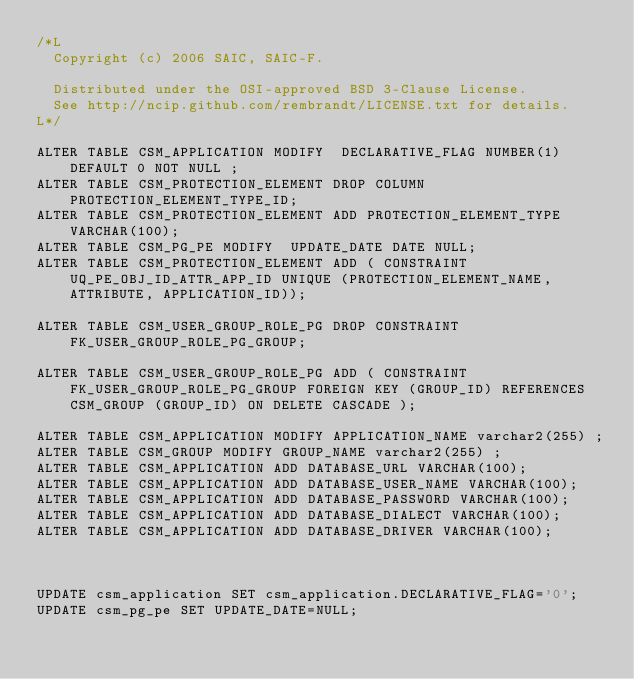Convert code to text. <code><loc_0><loc_0><loc_500><loc_500><_SQL_>/*L
  Copyright (c) 2006 SAIC, SAIC-F.

  Distributed under the OSI-approved BSD 3-Clause License.
  See http://ncip.github.com/rembrandt/LICENSE.txt for details.
L*/

ALTER TABLE CSM_APPLICATION MODIFY  DECLARATIVE_FLAG NUMBER(1) DEFAULT 0 NOT NULL ;
ALTER TABLE CSM_PROTECTION_ELEMENT DROP COLUMN PROTECTION_ELEMENT_TYPE_ID;
ALTER TABLE CSM_PROTECTION_ELEMENT ADD PROTECTION_ELEMENT_TYPE VARCHAR(100);
ALTER TABLE CSM_PG_PE MODIFY  UPDATE_DATE DATE NULL;
ALTER TABLE CSM_PROTECTION_ELEMENT ADD ( CONSTRAINT UQ_PE_OBJ_ID_ATTR_APP_ID UNIQUE (PROTECTION_ELEMENT_NAME, ATTRIBUTE, APPLICATION_ID));

ALTER TABLE CSM_USER_GROUP_ROLE_PG DROP CONSTRAINT FK_USER_GROUP_ROLE_PG_GROUP;

ALTER TABLE CSM_USER_GROUP_ROLE_PG ADD ( CONSTRAINT FK_USER_GROUP_ROLE_PG_GROUP FOREIGN KEY (GROUP_ID) REFERENCES CSM_GROUP (GROUP_ID) ON DELETE CASCADE );

ALTER TABLE CSM_APPLICATION MODIFY APPLICATION_NAME varchar2(255) ;
ALTER TABLE CSM_GROUP MODIFY GROUP_NAME varchar2(255) ;
ALTER TABLE CSM_APPLICATION ADD DATABASE_URL VARCHAR(100);
ALTER TABLE CSM_APPLICATION ADD DATABASE_USER_NAME VARCHAR(100);
ALTER TABLE CSM_APPLICATION ADD DATABASE_PASSWORD VARCHAR(100);
ALTER TABLE CSM_APPLICATION ADD DATABASE_DIALECT VARCHAR(100);
ALTER TABLE CSM_APPLICATION ADD DATABASE_DRIVER VARCHAR(100);



UPDATE csm_application SET csm_application.DECLARATIVE_FLAG='0';
UPDATE csm_pg_pe SET UPDATE_DATE=NULL;
</code> 